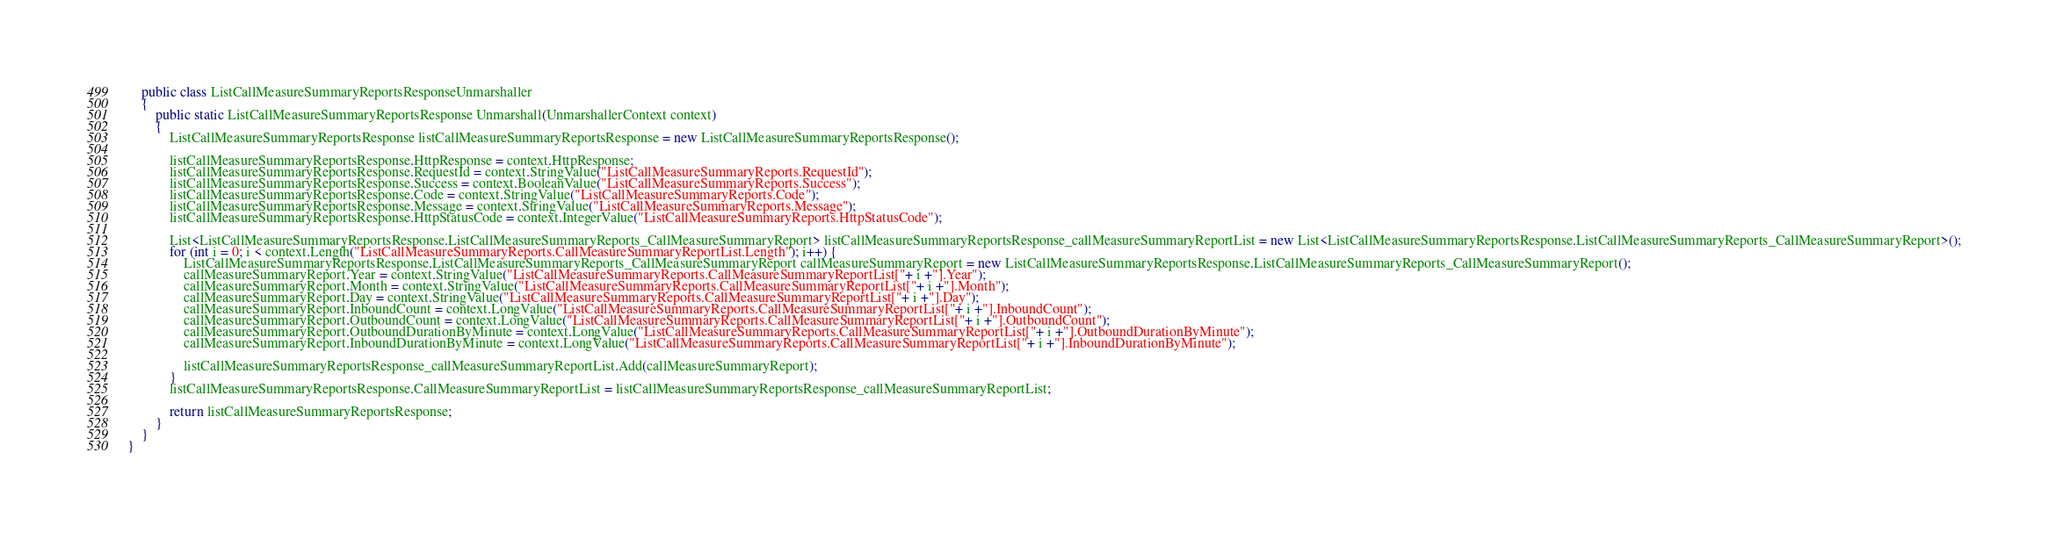<code> <loc_0><loc_0><loc_500><loc_500><_C#_>    public class ListCallMeasureSummaryReportsResponseUnmarshaller
    {
        public static ListCallMeasureSummaryReportsResponse Unmarshall(UnmarshallerContext context)
        {
			ListCallMeasureSummaryReportsResponse listCallMeasureSummaryReportsResponse = new ListCallMeasureSummaryReportsResponse();

			listCallMeasureSummaryReportsResponse.HttpResponse = context.HttpResponse;
			listCallMeasureSummaryReportsResponse.RequestId = context.StringValue("ListCallMeasureSummaryReports.RequestId");
			listCallMeasureSummaryReportsResponse.Success = context.BooleanValue("ListCallMeasureSummaryReports.Success");
			listCallMeasureSummaryReportsResponse.Code = context.StringValue("ListCallMeasureSummaryReports.Code");
			listCallMeasureSummaryReportsResponse.Message = context.StringValue("ListCallMeasureSummaryReports.Message");
			listCallMeasureSummaryReportsResponse.HttpStatusCode = context.IntegerValue("ListCallMeasureSummaryReports.HttpStatusCode");

			List<ListCallMeasureSummaryReportsResponse.ListCallMeasureSummaryReports_CallMeasureSummaryReport> listCallMeasureSummaryReportsResponse_callMeasureSummaryReportList = new List<ListCallMeasureSummaryReportsResponse.ListCallMeasureSummaryReports_CallMeasureSummaryReport>();
			for (int i = 0; i < context.Length("ListCallMeasureSummaryReports.CallMeasureSummaryReportList.Length"); i++) {
				ListCallMeasureSummaryReportsResponse.ListCallMeasureSummaryReports_CallMeasureSummaryReport callMeasureSummaryReport = new ListCallMeasureSummaryReportsResponse.ListCallMeasureSummaryReports_CallMeasureSummaryReport();
				callMeasureSummaryReport.Year = context.StringValue("ListCallMeasureSummaryReports.CallMeasureSummaryReportList["+ i +"].Year");
				callMeasureSummaryReport.Month = context.StringValue("ListCallMeasureSummaryReports.CallMeasureSummaryReportList["+ i +"].Month");
				callMeasureSummaryReport.Day = context.StringValue("ListCallMeasureSummaryReports.CallMeasureSummaryReportList["+ i +"].Day");
				callMeasureSummaryReport.InboundCount = context.LongValue("ListCallMeasureSummaryReports.CallMeasureSummaryReportList["+ i +"].InboundCount");
				callMeasureSummaryReport.OutboundCount = context.LongValue("ListCallMeasureSummaryReports.CallMeasureSummaryReportList["+ i +"].OutboundCount");
				callMeasureSummaryReport.OutboundDurationByMinute = context.LongValue("ListCallMeasureSummaryReports.CallMeasureSummaryReportList["+ i +"].OutboundDurationByMinute");
				callMeasureSummaryReport.InboundDurationByMinute = context.LongValue("ListCallMeasureSummaryReports.CallMeasureSummaryReportList["+ i +"].InboundDurationByMinute");

				listCallMeasureSummaryReportsResponse_callMeasureSummaryReportList.Add(callMeasureSummaryReport);
			}
			listCallMeasureSummaryReportsResponse.CallMeasureSummaryReportList = listCallMeasureSummaryReportsResponse_callMeasureSummaryReportList;
        
			return listCallMeasureSummaryReportsResponse;
        }
    }
}
</code> 